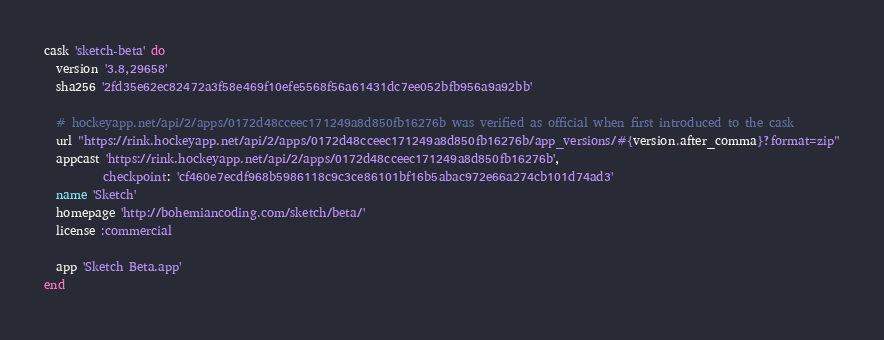<code> <loc_0><loc_0><loc_500><loc_500><_Ruby_>cask 'sketch-beta' do
  version '3.8,29658'
  sha256 '2fd35e62ec82472a3f58e469f10efe5568f56a61431dc7ee052bfb956a9a92bb'

  # hockeyapp.net/api/2/apps/0172d48cceec171249a8d850fb16276b was verified as official when first introduced to the cask
  url "https://rink.hockeyapp.net/api/2/apps/0172d48cceec171249a8d850fb16276b/app_versions/#{version.after_comma}?format=zip"
  appcast 'https://rink.hockeyapp.net/api/2/apps/0172d48cceec171249a8d850fb16276b',
          checkpoint: 'cf460e7ecdf968b5986118c9c3ce86101bf16b5abac972e66a274cb101d74ad3'
  name 'Sketch'
  homepage 'http://bohemiancoding.com/sketch/beta/'
  license :commercial

  app 'Sketch Beta.app'
end
</code> 